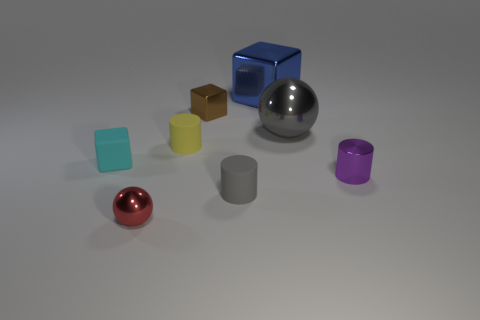Subtract all brown spheres. Subtract all purple cylinders. How many spheres are left? 2 Add 1 small red shiny things. How many objects exist? 9 Subtract all spheres. How many objects are left? 6 Subtract all spheres. Subtract all large blue blocks. How many objects are left? 5 Add 6 big blue metallic objects. How many big blue metallic objects are left? 7 Add 1 purple metal cylinders. How many purple metal cylinders exist? 2 Subtract 1 purple cylinders. How many objects are left? 7 